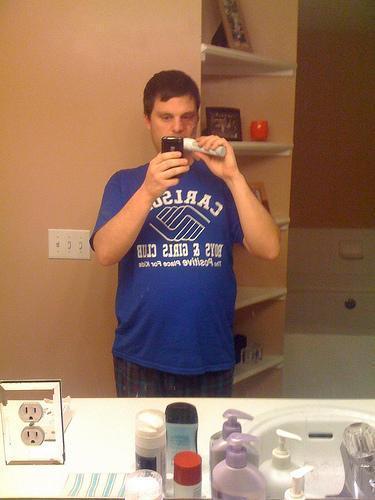How many pumps are on the counter?
Give a very brief answer. 4. 